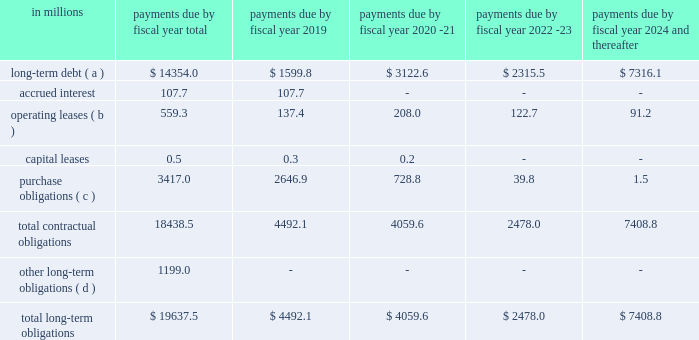Obligations of non-consolidated affiliates , mainly cpw .
In addition , off-balance sheet arrangements are generally limited to the future payments under non-cancelable operating leases , which totaled $ 559 million as of may 27 , as of may 27 , 2018 , we had invested in five variable interest entities ( vies ) .
None of our vies are material to our results of operations , financial condition , or liquidity as of and for the fiscal year ended may 27 , 2018 .
Our defined benefit plans in the united states are subject to the requirements of the pension protection act ( ppa ) .
In the future , the ppa may require us to make additional contributions to our domestic plans .
We do not expect to be required to make any contributions in fiscal 2019 .
The table summarizes our future estimated cash payments under existing contractual obligations , including payments due by period: .
( a ) amounts represent the expected cash payments of our long-term debt and do not include $ 0.5 million for capital leases or $ 85.7 million for net unamortized debt issuance costs , premiums and discounts , and fair value adjustments .
( b ) operating leases represents the minimum rental commitments under non-cancelable operating leases .
( c ) the majority of the purchase obligations represent commitments for raw material and packaging to be utilized in the normal course of business and for consumer marketing spending commitments that support our brands .
For purposes of this table , arrangements are considered purchase obligations if a contract specifies all significant terms , including fixed or minimum quantities to be purchased , a pricing structure , and approximate timing of the transaction .
Most arrangements are cancelable without a significant penalty and with short notice ( usually 30 days ) .
Any amounts reflected on the consolidated balance sheets as accounts payable and accrued liabilities are excluded from the table above .
( d ) the fair value of our foreign exchange , equity , commodity , and grain derivative contracts with a payable position to the counterparty was $ 16 million as of may 27 , 2018 , based on fair market values as of that date .
Future changes in market values will impact the amount of cash ultimately paid or received to settle those instruments in the future .
Other long-term obligations mainly consist of liabilities for accrued compensation and benefits , including the underfunded status of certain of our defined benefit pension , other postretirement benefit , and postemployment benefit plans , and miscellaneous liabilities .
We expect to pay $ 20 million of benefits from our unfunded postemployment benefit plans and $ 18 million of deferred compensation in fiscal 2019 .
We are unable to reliably estimate the amount of these payments beyond fiscal 2019 .
As of may 27 , 2018 , our total liability for uncertain tax positions and accrued interest and penalties was $ 223.6 million .
Significant accounting estimates for a complete description of our significant accounting policies , please see note 2 to the consolidated financial statements in item 8 of this report .
Our significant accounting estimates are those that have a meaningful impact .
In 2019 what was the ratio of the anticipated future payments for the post-employment benefit plans and deferred compensation? 
Computations: (20 / 18)
Answer: 1.11111. 